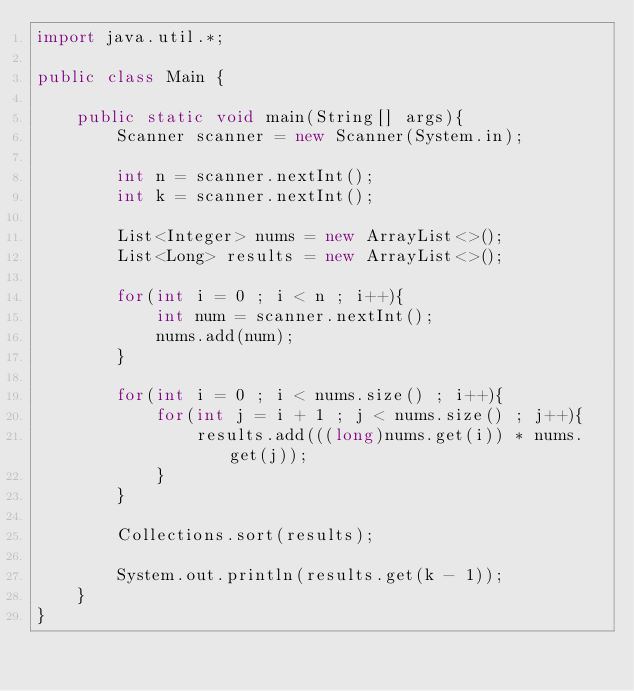Convert code to text. <code><loc_0><loc_0><loc_500><loc_500><_Java_>import java.util.*;

public class Main {

    public static void main(String[] args){
        Scanner scanner = new Scanner(System.in);

        int n = scanner.nextInt();
        int k = scanner.nextInt();

        List<Integer> nums = new ArrayList<>();
        List<Long> results = new ArrayList<>();

        for(int i = 0 ; i < n ; i++){
            int num = scanner.nextInt();
            nums.add(num);
        }

        for(int i = 0 ; i < nums.size() ; i++){
            for(int j = i + 1 ; j < nums.size() ; j++){
                results.add(((long)nums.get(i)) * nums.get(j));
            }
        }

        Collections.sort(results);

        System.out.println(results.get(k - 1));
    }
}</code> 